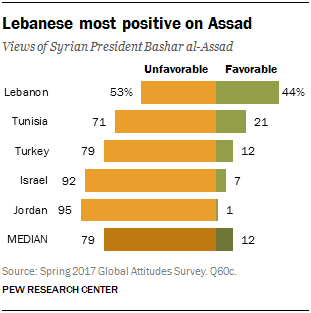Mention a couple of crucial points in this snapshot. Yes, there is a value of 1 on the bar graph. Jordan is the country with the highest gap between its two aspects. 